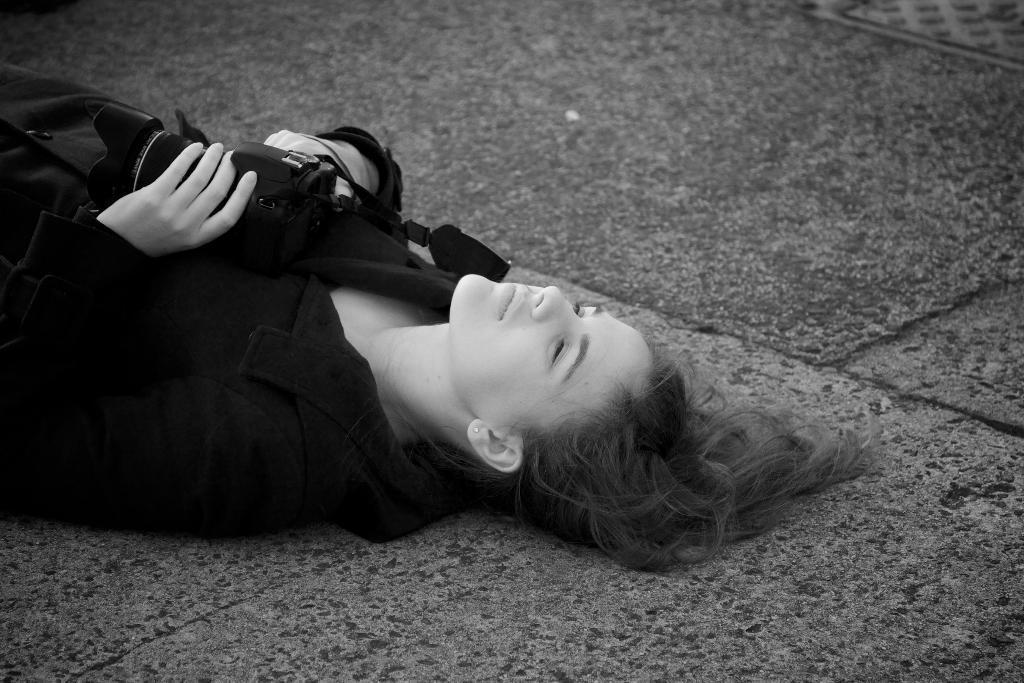Please provide a concise description of this image. There is a woman lying on floor holding camera. 